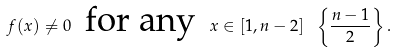<formula> <loc_0><loc_0><loc_500><loc_500>f ( x ) \neq 0 \, \text { for any } \, x \in [ 1 , n - 2 ] \ \left \{ \frac { n - 1 } { 2 } \right \} .</formula> 